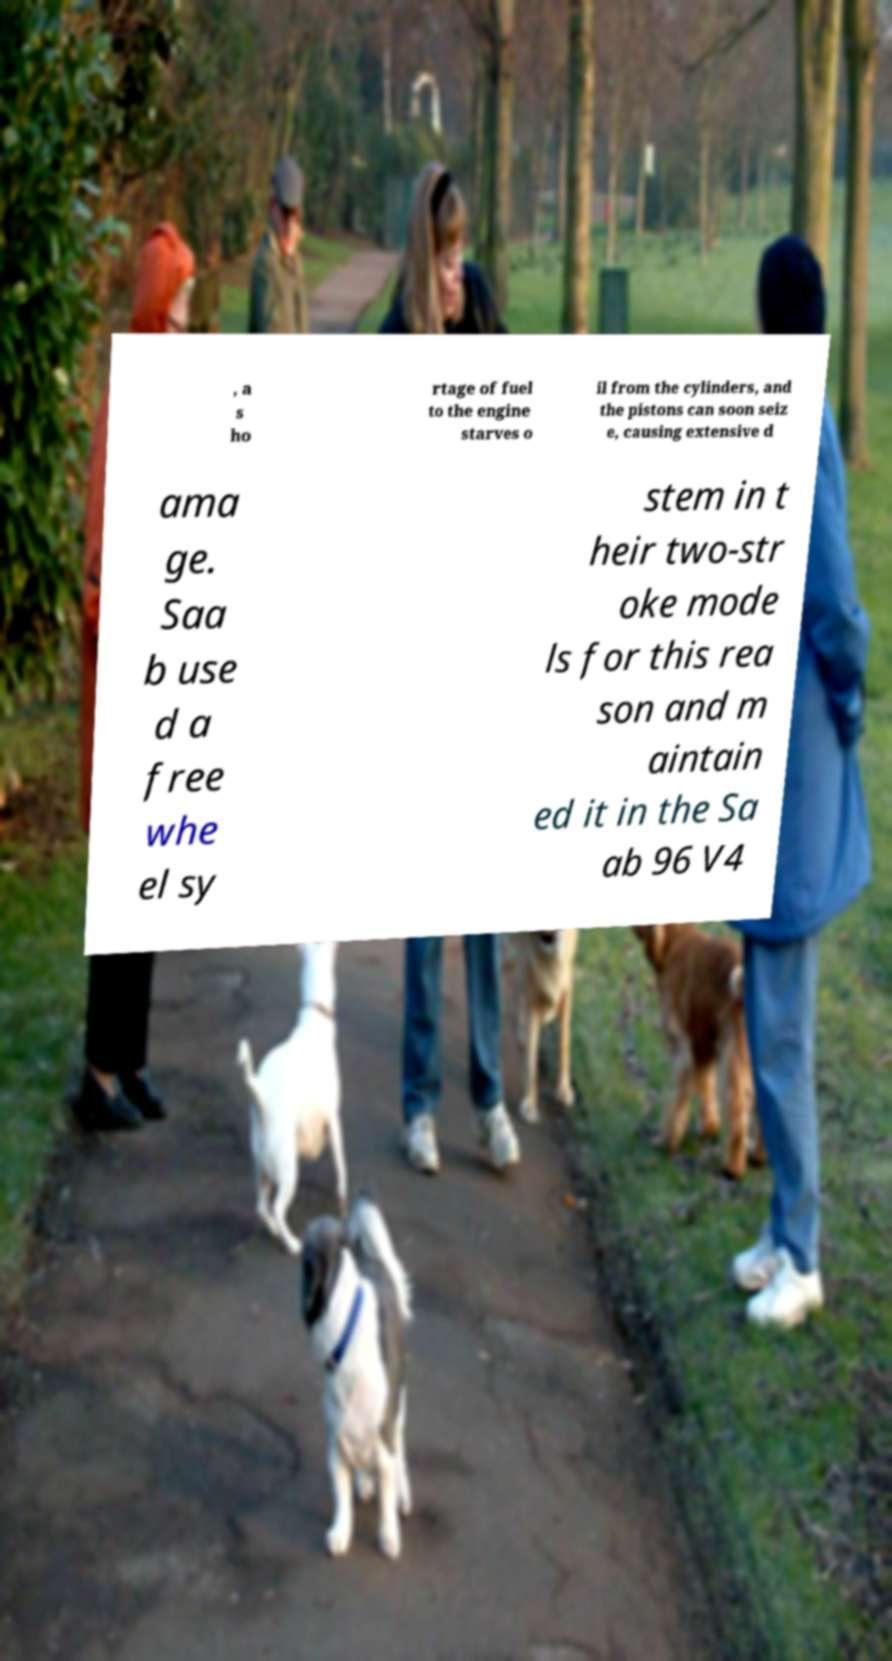Can you read and provide the text displayed in the image?This photo seems to have some interesting text. Can you extract and type it out for me? , a s ho rtage of fuel to the engine starves o il from the cylinders, and the pistons can soon seiz e, causing extensive d ama ge. Saa b use d a free whe el sy stem in t heir two-str oke mode ls for this rea son and m aintain ed it in the Sa ab 96 V4 